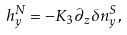<formula> <loc_0><loc_0><loc_500><loc_500>h ^ { N } _ { y } = - K _ { 3 } \partial _ { z } \delta n ^ { S } _ { y } ,</formula> 